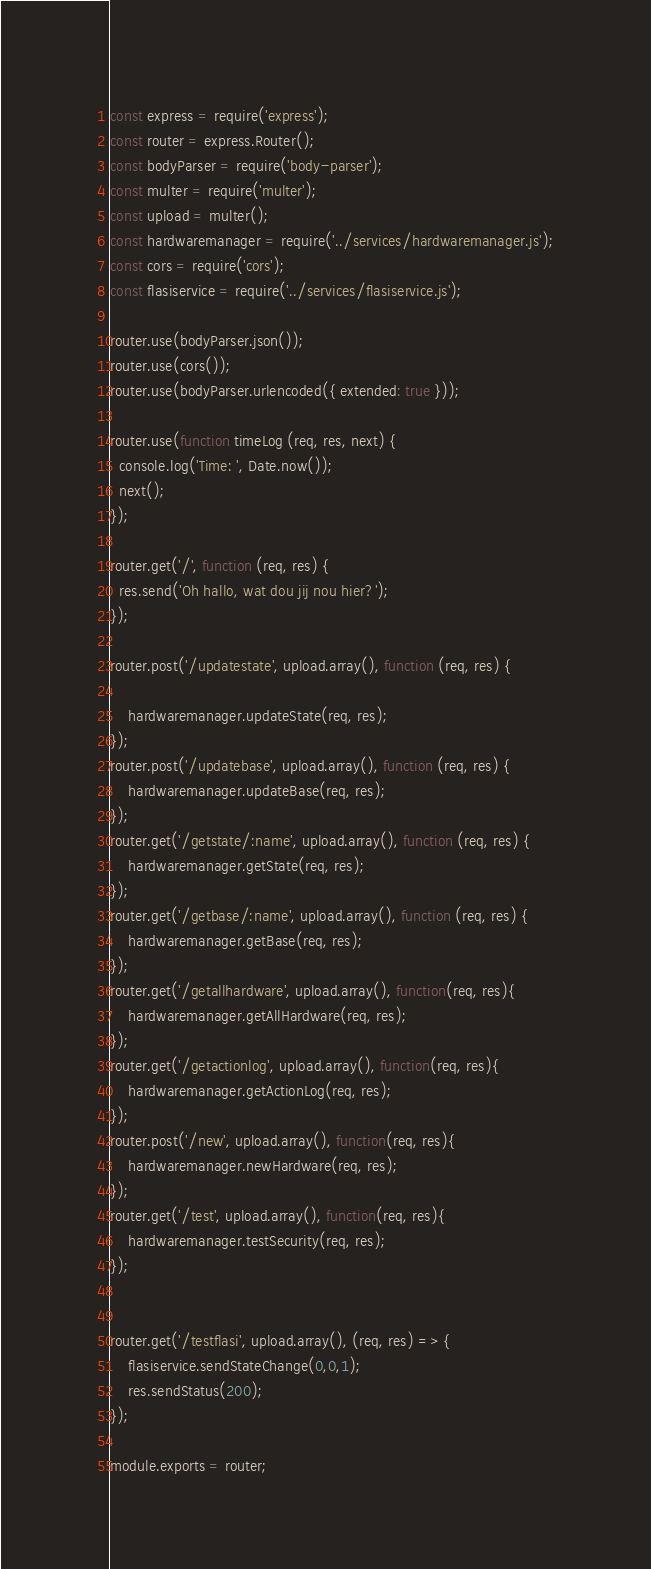Convert code to text. <code><loc_0><loc_0><loc_500><loc_500><_JavaScript_>const express = require('express');
const router = express.Router();
const bodyParser = require('body-parser');
const multer = require('multer');
const upload = multer();
const hardwaremanager = require('../services/hardwaremanager.js');
const cors = require('cors');
const flasiservice = require('../services/flasiservice.js');

router.use(bodyParser.json());
router.use(cors());
router.use(bodyParser.urlencoded({ extended: true }));

router.use(function timeLog (req, res, next) {
  console.log('Time: ', Date.now());
  next();
});

router.get('/', function (req, res) {
  res.send('Oh hallo, wat dou jij nou hier?');
});

router.post('/updatestate', upload.array(), function (req, res) {

    hardwaremanager.updateState(req, res);
});
router.post('/updatebase', upload.array(), function (req, res) {
    hardwaremanager.updateBase(req, res);
});
router.get('/getstate/:name', upload.array(), function (req, res) {
    hardwaremanager.getState(req, res);
});
router.get('/getbase/:name', upload.array(), function (req, res) {
    hardwaremanager.getBase(req, res);
});
router.get('/getallhardware', upload.array(), function(req, res){
    hardwaremanager.getAllHardware(req, res);
});
router.get('/getactionlog', upload.array(), function(req, res){
    hardwaremanager.getActionLog(req, res);
});
router.post('/new', upload.array(), function(req, res){
    hardwaremanager.newHardware(req, res);
});
router.get('/test', upload.array(), function(req, res){
    hardwaremanager.testSecurity(req, res);
});


router.get('/testflasi', upload.array(), (req, res) => {
    flasiservice.sendStateChange(0,0,1);
    res.sendStatus(200);
});

module.exports = router;
</code> 